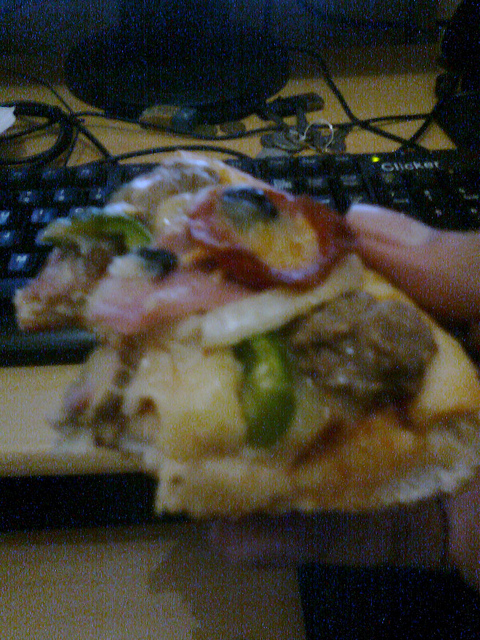Is there a glass of wine? No, there is no visible glass of wine or any other drink in the image. 